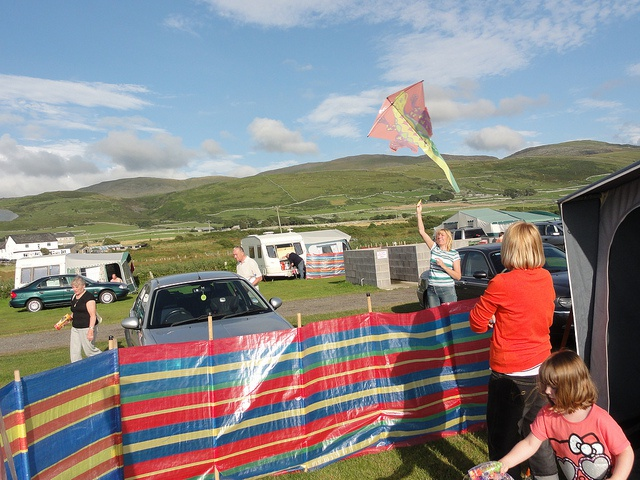Describe the objects in this image and their specific colors. I can see people in gray, black, red, and salmon tones, car in gray, black, and darkgray tones, people in gray, salmon, maroon, and black tones, car in gray, black, and purple tones, and kite in gray, lightpink, khaki, darkgray, and olive tones in this image. 